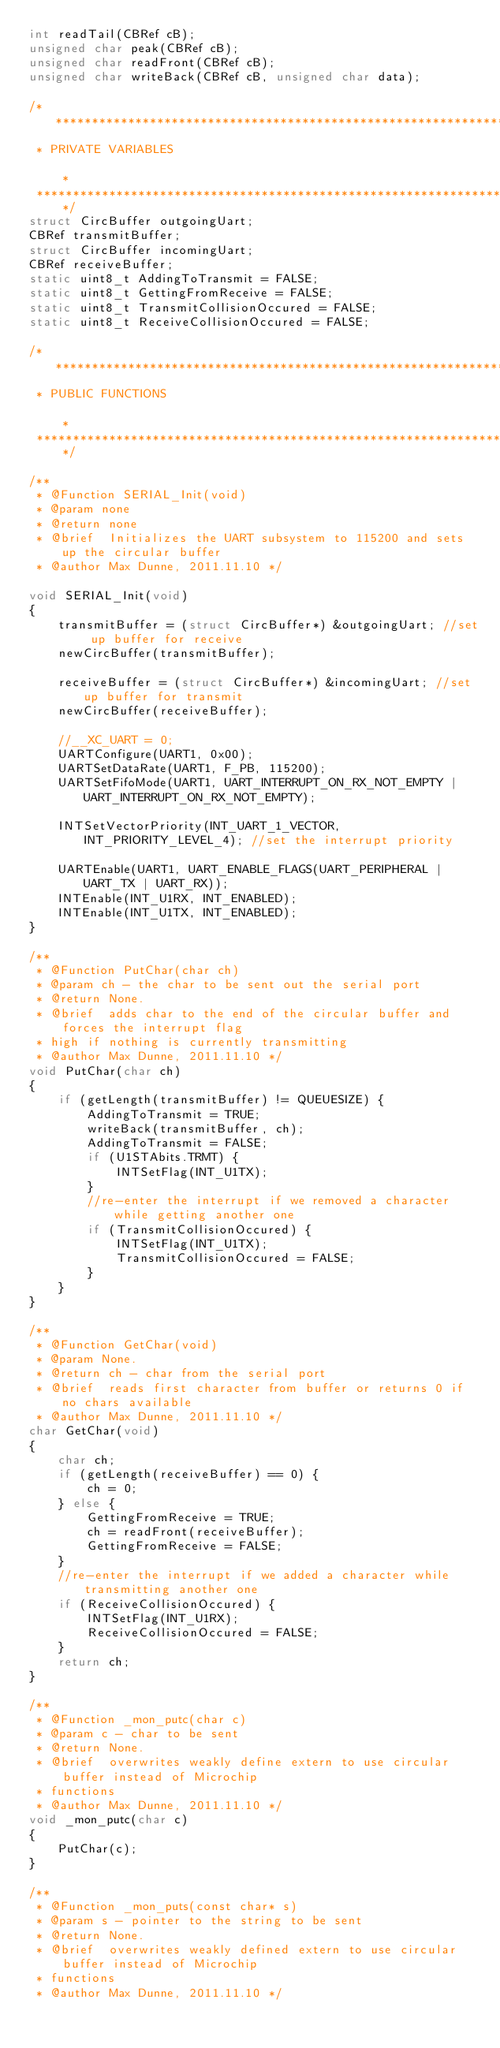<code> <loc_0><loc_0><loc_500><loc_500><_C_>int readTail(CBRef cB);
unsigned char peak(CBRef cB);
unsigned char readFront(CBRef cB);
unsigned char writeBack(CBRef cB, unsigned char data);

/*******************************************************************************
 * PRIVATE VARIABLES                                                           *
 ******************************************************************************/
struct CircBuffer outgoingUart;
CBRef transmitBuffer;
struct CircBuffer incomingUart;
CBRef receiveBuffer;
static uint8_t AddingToTransmit = FALSE;
static uint8_t GettingFromReceive = FALSE;
static uint8_t TransmitCollisionOccured = FALSE;
static uint8_t ReceiveCollisionOccured = FALSE;

/*******************************************************************************
 * PUBLIC FUNCTIONS                                                           *
 ******************************************************************************/

/**
 * @Function SERIAL_Init(void)
 * @param none
 * @return none
 * @brief  Initializes the UART subsystem to 115200 and sets up the circular buffer
 * @author Max Dunne, 2011.11.10 */

void SERIAL_Init(void)
{
    transmitBuffer = (struct CircBuffer*) &outgoingUart; //set up buffer for receive
    newCircBuffer(transmitBuffer);

    receiveBuffer = (struct CircBuffer*) &incomingUart; //set up buffer for transmit
    newCircBuffer(receiveBuffer);

    //__XC_UART = 0;
    UARTConfigure(UART1, 0x00);
    UARTSetDataRate(UART1, F_PB, 115200);
    UARTSetFifoMode(UART1, UART_INTERRUPT_ON_RX_NOT_EMPTY | UART_INTERRUPT_ON_RX_NOT_EMPTY);

    INTSetVectorPriority(INT_UART_1_VECTOR, INT_PRIORITY_LEVEL_4); //set the interrupt priority

    UARTEnable(UART1, UART_ENABLE_FLAGS(UART_PERIPHERAL | UART_TX | UART_RX));
    INTEnable(INT_U1RX, INT_ENABLED);
    INTEnable(INT_U1TX, INT_ENABLED);
}

/**
 * @Function PutChar(char ch)
 * @param ch - the char to be sent out the serial port
 * @return None.
 * @brief  adds char to the end of the circular buffer and forces the interrupt flag 
 * high if nothing is currently transmitting
 * @author Max Dunne, 2011.11.10 */
void PutChar(char ch)
{
    if (getLength(transmitBuffer) != QUEUESIZE) {
        AddingToTransmit = TRUE;
        writeBack(transmitBuffer, ch);
        AddingToTransmit = FALSE;
        if (U1STAbits.TRMT) {
            INTSetFlag(INT_U1TX);
        }
        //re-enter the interrupt if we removed a character while getting another one
        if (TransmitCollisionOccured) {
            INTSetFlag(INT_U1TX);
            TransmitCollisionOccured = FALSE;
        }
    }
}

/**
 * @Function GetChar(void)
 * @param None.
 * @return ch - char from the serial port
 * @brief  reads first character from buffer or returns 0 if no chars available
 * @author Max Dunne, 2011.11.10 */
char GetChar(void)
{
    char ch;
    if (getLength(receiveBuffer) == 0) {
        ch = 0;
    } else {
        GettingFromReceive = TRUE;
        ch = readFront(receiveBuffer);
        GettingFromReceive = FALSE;
    }
    //re-enter the interrupt if we added a character while transmitting another one
    if (ReceiveCollisionOccured) {
        INTSetFlag(INT_U1RX);
        ReceiveCollisionOccured = FALSE;
    }
    return ch;
}

/**
 * @Function _mon_putc(char c)
 * @param c - char to be sent
 * @return None.
 * @brief  overwrites weakly define extern to use circular buffer instead of Microchip 
 * functions
 * @author Max Dunne, 2011.11.10 */
void _mon_putc(char c)
{
    PutChar(c);
}

/**
 * @Function _mon_puts(const char* s)
 * @param s - pointer to the string to be sent
 * @return None.
 * @brief  overwrites weakly defined extern to use circular buffer instead of Microchip 
 * functions
 * @author Max Dunne, 2011.11.10 */</code> 